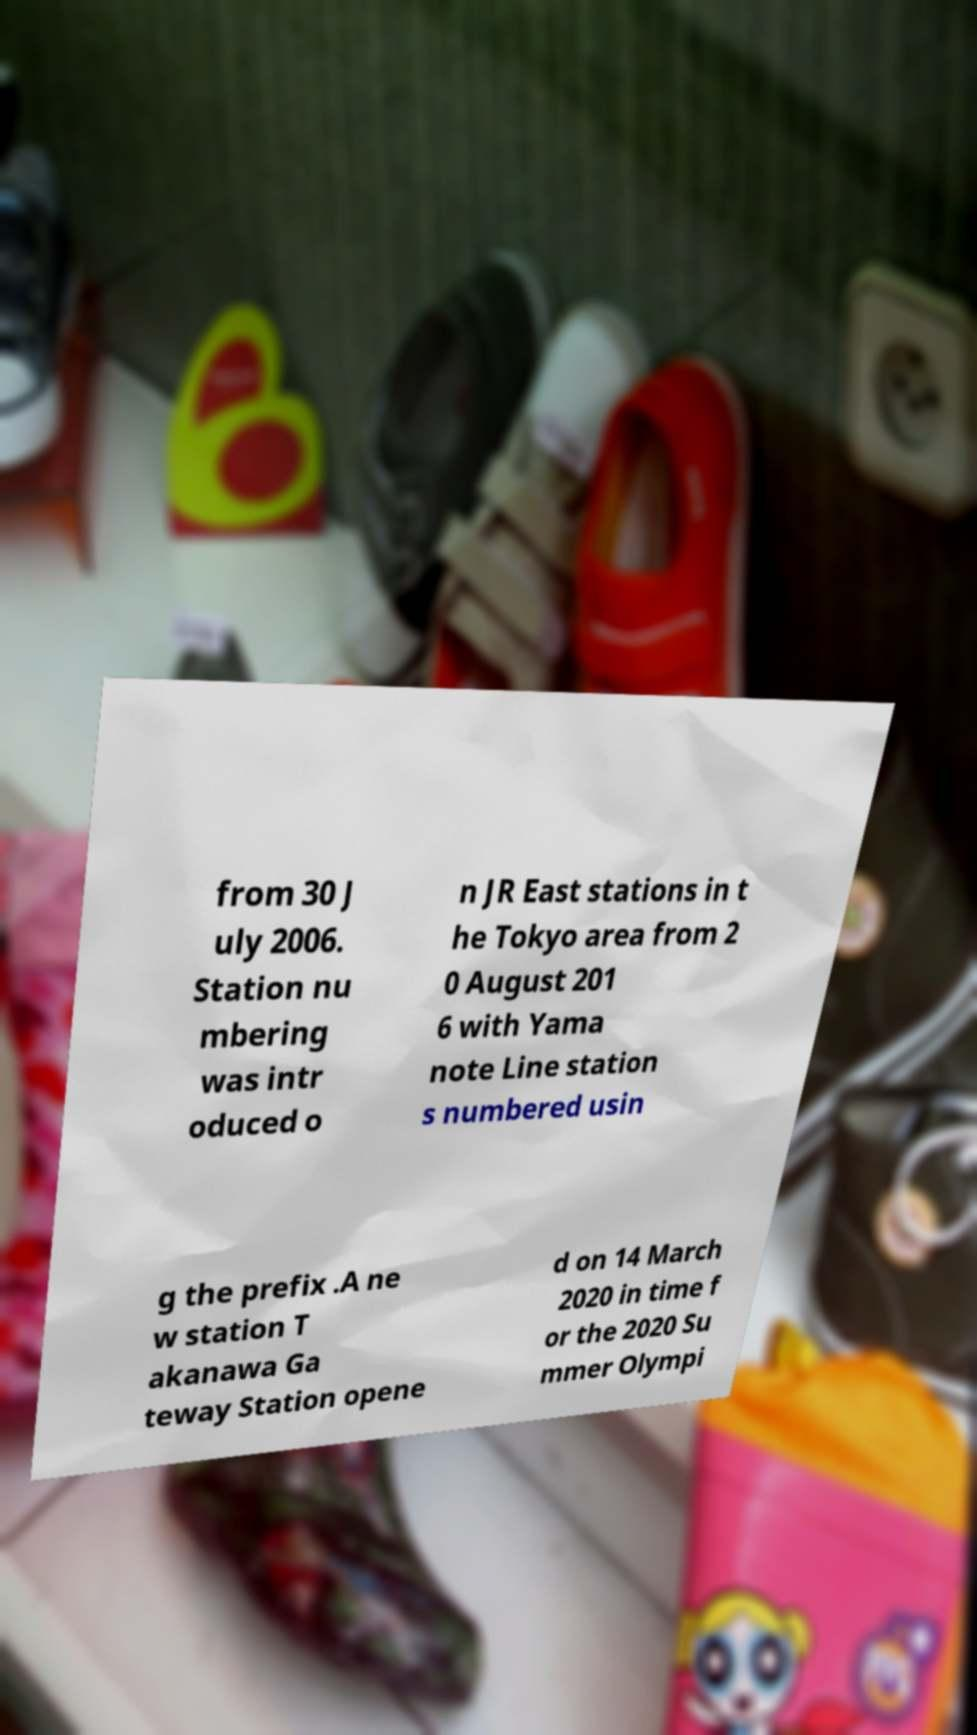Can you accurately transcribe the text from the provided image for me? from 30 J uly 2006. Station nu mbering was intr oduced o n JR East stations in t he Tokyo area from 2 0 August 201 6 with Yama note Line station s numbered usin g the prefix .A ne w station T akanawa Ga teway Station opene d on 14 March 2020 in time f or the 2020 Su mmer Olympi 